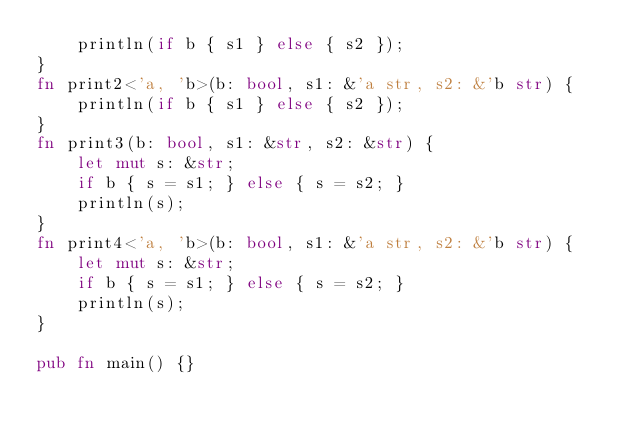Convert code to text. <code><loc_0><loc_0><loc_500><loc_500><_Rust_>    println(if b { s1 } else { s2 });
}
fn print2<'a, 'b>(b: bool, s1: &'a str, s2: &'b str) {
    println(if b { s1 } else { s2 });
}
fn print3(b: bool, s1: &str, s2: &str) {
    let mut s: &str;
    if b { s = s1; } else { s = s2; }
    println(s);
}
fn print4<'a, 'b>(b: bool, s1: &'a str, s2: &'b str) {
    let mut s: &str;
    if b { s = s1; } else { s = s2; }
    println(s);
}

pub fn main() {}
</code> 